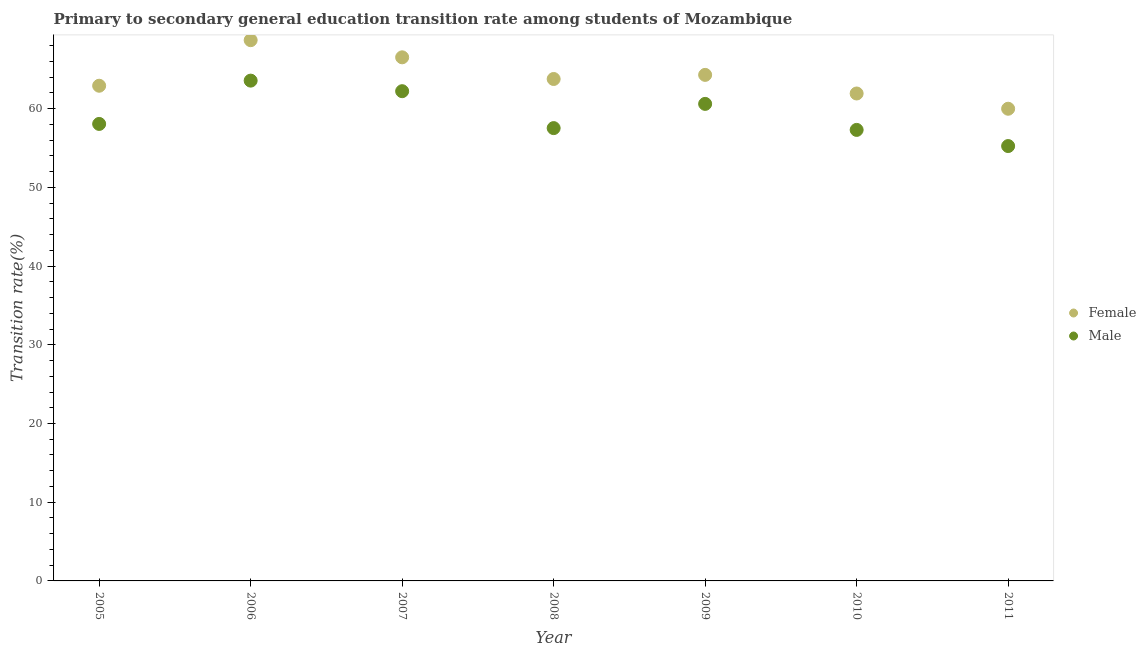Is the number of dotlines equal to the number of legend labels?
Offer a very short reply. Yes. What is the transition rate among female students in 2010?
Your answer should be very brief. 61.92. Across all years, what is the maximum transition rate among female students?
Your response must be concise. 68.7. Across all years, what is the minimum transition rate among male students?
Ensure brevity in your answer.  55.25. What is the total transition rate among female students in the graph?
Your response must be concise. 448.09. What is the difference between the transition rate among male students in 2006 and that in 2010?
Keep it short and to the point. 6.26. What is the difference between the transition rate among male students in 2007 and the transition rate among female students in 2008?
Your response must be concise. -1.55. What is the average transition rate among male students per year?
Ensure brevity in your answer.  59.22. In the year 2008, what is the difference between the transition rate among female students and transition rate among male students?
Give a very brief answer. 6.24. What is the ratio of the transition rate among female students in 2005 to that in 2007?
Make the answer very short. 0.95. Is the transition rate among male students in 2010 less than that in 2011?
Keep it short and to the point. No. What is the difference between the highest and the second highest transition rate among male students?
Ensure brevity in your answer.  1.34. What is the difference between the highest and the lowest transition rate among male students?
Give a very brief answer. 8.31. In how many years, is the transition rate among male students greater than the average transition rate among male students taken over all years?
Make the answer very short. 3. Does the transition rate among female students monotonically increase over the years?
Give a very brief answer. No. Is the transition rate among female students strictly less than the transition rate among male students over the years?
Offer a terse response. No. How many dotlines are there?
Provide a succinct answer. 2. What is the difference between two consecutive major ticks on the Y-axis?
Provide a succinct answer. 10. Where does the legend appear in the graph?
Your response must be concise. Center right. How many legend labels are there?
Make the answer very short. 2. How are the legend labels stacked?
Your response must be concise. Vertical. What is the title of the graph?
Your response must be concise. Primary to secondary general education transition rate among students of Mozambique. Does "DAC donors" appear as one of the legend labels in the graph?
Provide a succinct answer. No. What is the label or title of the X-axis?
Ensure brevity in your answer.  Year. What is the label or title of the Y-axis?
Provide a short and direct response. Transition rate(%). What is the Transition rate(%) in Female in 2005?
Offer a very short reply. 62.91. What is the Transition rate(%) in Male in 2005?
Ensure brevity in your answer.  58.06. What is the Transition rate(%) of Female in 2006?
Offer a very short reply. 68.7. What is the Transition rate(%) of Male in 2006?
Offer a very short reply. 63.56. What is the Transition rate(%) in Female in 2007?
Provide a succinct answer. 66.52. What is the Transition rate(%) of Male in 2007?
Offer a terse response. 62.22. What is the Transition rate(%) of Female in 2008?
Your answer should be very brief. 63.77. What is the Transition rate(%) of Male in 2008?
Offer a very short reply. 57.53. What is the Transition rate(%) in Female in 2009?
Provide a short and direct response. 64.29. What is the Transition rate(%) of Male in 2009?
Provide a short and direct response. 60.6. What is the Transition rate(%) of Female in 2010?
Make the answer very short. 61.92. What is the Transition rate(%) of Male in 2010?
Your answer should be very brief. 57.3. What is the Transition rate(%) in Female in 2011?
Your response must be concise. 59.99. What is the Transition rate(%) of Male in 2011?
Give a very brief answer. 55.25. Across all years, what is the maximum Transition rate(%) of Female?
Give a very brief answer. 68.7. Across all years, what is the maximum Transition rate(%) of Male?
Make the answer very short. 63.56. Across all years, what is the minimum Transition rate(%) in Female?
Your answer should be compact. 59.99. Across all years, what is the minimum Transition rate(%) of Male?
Provide a succinct answer. 55.25. What is the total Transition rate(%) of Female in the graph?
Make the answer very short. 448.09. What is the total Transition rate(%) in Male in the graph?
Provide a succinct answer. 414.51. What is the difference between the Transition rate(%) of Female in 2005 and that in 2006?
Your answer should be compact. -5.79. What is the difference between the Transition rate(%) in Male in 2005 and that in 2006?
Provide a succinct answer. -5.5. What is the difference between the Transition rate(%) in Female in 2005 and that in 2007?
Offer a very short reply. -3.61. What is the difference between the Transition rate(%) in Male in 2005 and that in 2007?
Provide a short and direct response. -4.16. What is the difference between the Transition rate(%) in Female in 2005 and that in 2008?
Give a very brief answer. -0.86. What is the difference between the Transition rate(%) in Male in 2005 and that in 2008?
Ensure brevity in your answer.  0.53. What is the difference between the Transition rate(%) in Female in 2005 and that in 2009?
Your answer should be very brief. -1.38. What is the difference between the Transition rate(%) in Male in 2005 and that in 2009?
Ensure brevity in your answer.  -2.55. What is the difference between the Transition rate(%) in Male in 2005 and that in 2010?
Keep it short and to the point. 0.76. What is the difference between the Transition rate(%) of Female in 2005 and that in 2011?
Offer a terse response. 2.92. What is the difference between the Transition rate(%) of Male in 2005 and that in 2011?
Provide a succinct answer. 2.81. What is the difference between the Transition rate(%) of Female in 2006 and that in 2007?
Provide a short and direct response. 2.18. What is the difference between the Transition rate(%) in Male in 2006 and that in 2007?
Ensure brevity in your answer.  1.34. What is the difference between the Transition rate(%) in Female in 2006 and that in 2008?
Offer a very short reply. 4.93. What is the difference between the Transition rate(%) in Male in 2006 and that in 2008?
Provide a succinct answer. 6.03. What is the difference between the Transition rate(%) in Female in 2006 and that in 2009?
Ensure brevity in your answer.  4.41. What is the difference between the Transition rate(%) of Male in 2006 and that in 2009?
Ensure brevity in your answer.  2.95. What is the difference between the Transition rate(%) of Female in 2006 and that in 2010?
Ensure brevity in your answer.  6.77. What is the difference between the Transition rate(%) in Male in 2006 and that in 2010?
Ensure brevity in your answer.  6.26. What is the difference between the Transition rate(%) of Female in 2006 and that in 2011?
Your response must be concise. 8.71. What is the difference between the Transition rate(%) in Male in 2006 and that in 2011?
Offer a terse response. 8.31. What is the difference between the Transition rate(%) of Female in 2007 and that in 2008?
Provide a short and direct response. 2.75. What is the difference between the Transition rate(%) in Male in 2007 and that in 2008?
Your answer should be compact. 4.69. What is the difference between the Transition rate(%) of Female in 2007 and that in 2009?
Provide a succinct answer. 2.23. What is the difference between the Transition rate(%) in Male in 2007 and that in 2009?
Make the answer very short. 1.61. What is the difference between the Transition rate(%) of Female in 2007 and that in 2010?
Your answer should be very brief. 4.59. What is the difference between the Transition rate(%) in Male in 2007 and that in 2010?
Make the answer very short. 4.92. What is the difference between the Transition rate(%) of Female in 2007 and that in 2011?
Offer a terse response. 6.53. What is the difference between the Transition rate(%) in Male in 2007 and that in 2011?
Provide a succinct answer. 6.97. What is the difference between the Transition rate(%) of Female in 2008 and that in 2009?
Make the answer very short. -0.52. What is the difference between the Transition rate(%) of Male in 2008 and that in 2009?
Provide a succinct answer. -3.08. What is the difference between the Transition rate(%) of Female in 2008 and that in 2010?
Your answer should be compact. 1.84. What is the difference between the Transition rate(%) in Male in 2008 and that in 2010?
Ensure brevity in your answer.  0.23. What is the difference between the Transition rate(%) of Female in 2008 and that in 2011?
Your response must be concise. 3.78. What is the difference between the Transition rate(%) in Male in 2008 and that in 2011?
Offer a very short reply. 2.28. What is the difference between the Transition rate(%) of Female in 2009 and that in 2010?
Ensure brevity in your answer.  2.36. What is the difference between the Transition rate(%) in Male in 2009 and that in 2010?
Your response must be concise. 3.3. What is the difference between the Transition rate(%) in Female in 2009 and that in 2011?
Keep it short and to the point. 4.3. What is the difference between the Transition rate(%) in Male in 2009 and that in 2011?
Offer a terse response. 5.36. What is the difference between the Transition rate(%) in Female in 2010 and that in 2011?
Ensure brevity in your answer.  1.94. What is the difference between the Transition rate(%) in Male in 2010 and that in 2011?
Provide a short and direct response. 2.05. What is the difference between the Transition rate(%) in Female in 2005 and the Transition rate(%) in Male in 2006?
Your answer should be very brief. -0.65. What is the difference between the Transition rate(%) in Female in 2005 and the Transition rate(%) in Male in 2007?
Give a very brief answer. 0.69. What is the difference between the Transition rate(%) in Female in 2005 and the Transition rate(%) in Male in 2008?
Your response must be concise. 5.38. What is the difference between the Transition rate(%) in Female in 2005 and the Transition rate(%) in Male in 2009?
Ensure brevity in your answer.  2.31. What is the difference between the Transition rate(%) of Female in 2005 and the Transition rate(%) of Male in 2010?
Offer a terse response. 5.61. What is the difference between the Transition rate(%) in Female in 2005 and the Transition rate(%) in Male in 2011?
Ensure brevity in your answer.  7.66. What is the difference between the Transition rate(%) of Female in 2006 and the Transition rate(%) of Male in 2007?
Your answer should be compact. 6.48. What is the difference between the Transition rate(%) of Female in 2006 and the Transition rate(%) of Male in 2008?
Keep it short and to the point. 11.17. What is the difference between the Transition rate(%) of Female in 2006 and the Transition rate(%) of Male in 2009?
Offer a very short reply. 8.1. What is the difference between the Transition rate(%) in Female in 2006 and the Transition rate(%) in Male in 2011?
Make the answer very short. 13.45. What is the difference between the Transition rate(%) of Female in 2007 and the Transition rate(%) of Male in 2008?
Provide a succinct answer. 8.99. What is the difference between the Transition rate(%) in Female in 2007 and the Transition rate(%) in Male in 2009?
Provide a succinct answer. 5.92. What is the difference between the Transition rate(%) of Female in 2007 and the Transition rate(%) of Male in 2010?
Make the answer very short. 9.22. What is the difference between the Transition rate(%) in Female in 2007 and the Transition rate(%) in Male in 2011?
Provide a succinct answer. 11.27. What is the difference between the Transition rate(%) in Female in 2008 and the Transition rate(%) in Male in 2009?
Your response must be concise. 3.16. What is the difference between the Transition rate(%) of Female in 2008 and the Transition rate(%) of Male in 2010?
Keep it short and to the point. 6.47. What is the difference between the Transition rate(%) of Female in 2008 and the Transition rate(%) of Male in 2011?
Give a very brief answer. 8.52. What is the difference between the Transition rate(%) of Female in 2009 and the Transition rate(%) of Male in 2010?
Provide a short and direct response. 6.99. What is the difference between the Transition rate(%) in Female in 2009 and the Transition rate(%) in Male in 2011?
Your response must be concise. 9.04. What is the difference between the Transition rate(%) in Female in 2010 and the Transition rate(%) in Male in 2011?
Your answer should be compact. 6.68. What is the average Transition rate(%) of Female per year?
Make the answer very short. 64.01. What is the average Transition rate(%) in Male per year?
Offer a terse response. 59.22. In the year 2005, what is the difference between the Transition rate(%) of Female and Transition rate(%) of Male?
Ensure brevity in your answer.  4.85. In the year 2006, what is the difference between the Transition rate(%) in Female and Transition rate(%) in Male?
Give a very brief answer. 5.14. In the year 2007, what is the difference between the Transition rate(%) in Female and Transition rate(%) in Male?
Keep it short and to the point. 4.3. In the year 2008, what is the difference between the Transition rate(%) of Female and Transition rate(%) of Male?
Give a very brief answer. 6.24. In the year 2009, what is the difference between the Transition rate(%) in Female and Transition rate(%) in Male?
Make the answer very short. 3.69. In the year 2010, what is the difference between the Transition rate(%) in Female and Transition rate(%) in Male?
Your response must be concise. 4.63. In the year 2011, what is the difference between the Transition rate(%) in Female and Transition rate(%) in Male?
Make the answer very short. 4.74. What is the ratio of the Transition rate(%) of Female in 2005 to that in 2006?
Your answer should be very brief. 0.92. What is the ratio of the Transition rate(%) of Male in 2005 to that in 2006?
Provide a succinct answer. 0.91. What is the ratio of the Transition rate(%) in Female in 2005 to that in 2007?
Your response must be concise. 0.95. What is the ratio of the Transition rate(%) of Male in 2005 to that in 2007?
Offer a terse response. 0.93. What is the ratio of the Transition rate(%) of Female in 2005 to that in 2008?
Make the answer very short. 0.99. What is the ratio of the Transition rate(%) in Male in 2005 to that in 2008?
Your response must be concise. 1.01. What is the ratio of the Transition rate(%) of Female in 2005 to that in 2009?
Provide a short and direct response. 0.98. What is the ratio of the Transition rate(%) in Male in 2005 to that in 2009?
Ensure brevity in your answer.  0.96. What is the ratio of the Transition rate(%) of Female in 2005 to that in 2010?
Offer a terse response. 1.02. What is the ratio of the Transition rate(%) of Male in 2005 to that in 2010?
Your response must be concise. 1.01. What is the ratio of the Transition rate(%) of Female in 2005 to that in 2011?
Give a very brief answer. 1.05. What is the ratio of the Transition rate(%) in Male in 2005 to that in 2011?
Your answer should be compact. 1.05. What is the ratio of the Transition rate(%) in Female in 2006 to that in 2007?
Ensure brevity in your answer.  1.03. What is the ratio of the Transition rate(%) in Male in 2006 to that in 2007?
Offer a very short reply. 1.02. What is the ratio of the Transition rate(%) in Female in 2006 to that in 2008?
Keep it short and to the point. 1.08. What is the ratio of the Transition rate(%) in Male in 2006 to that in 2008?
Give a very brief answer. 1.1. What is the ratio of the Transition rate(%) of Female in 2006 to that in 2009?
Make the answer very short. 1.07. What is the ratio of the Transition rate(%) of Male in 2006 to that in 2009?
Make the answer very short. 1.05. What is the ratio of the Transition rate(%) of Female in 2006 to that in 2010?
Offer a very short reply. 1.11. What is the ratio of the Transition rate(%) of Male in 2006 to that in 2010?
Your answer should be very brief. 1.11. What is the ratio of the Transition rate(%) in Female in 2006 to that in 2011?
Offer a very short reply. 1.15. What is the ratio of the Transition rate(%) of Male in 2006 to that in 2011?
Offer a terse response. 1.15. What is the ratio of the Transition rate(%) of Female in 2007 to that in 2008?
Your answer should be compact. 1.04. What is the ratio of the Transition rate(%) of Male in 2007 to that in 2008?
Offer a terse response. 1.08. What is the ratio of the Transition rate(%) of Female in 2007 to that in 2009?
Your response must be concise. 1.03. What is the ratio of the Transition rate(%) of Male in 2007 to that in 2009?
Your answer should be very brief. 1.03. What is the ratio of the Transition rate(%) in Female in 2007 to that in 2010?
Your answer should be compact. 1.07. What is the ratio of the Transition rate(%) of Male in 2007 to that in 2010?
Provide a succinct answer. 1.09. What is the ratio of the Transition rate(%) of Female in 2007 to that in 2011?
Offer a terse response. 1.11. What is the ratio of the Transition rate(%) of Male in 2007 to that in 2011?
Provide a short and direct response. 1.13. What is the ratio of the Transition rate(%) of Female in 2008 to that in 2009?
Give a very brief answer. 0.99. What is the ratio of the Transition rate(%) of Male in 2008 to that in 2009?
Your response must be concise. 0.95. What is the ratio of the Transition rate(%) of Female in 2008 to that in 2010?
Offer a terse response. 1.03. What is the ratio of the Transition rate(%) of Female in 2008 to that in 2011?
Ensure brevity in your answer.  1.06. What is the ratio of the Transition rate(%) of Male in 2008 to that in 2011?
Make the answer very short. 1.04. What is the ratio of the Transition rate(%) of Female in 2009 to that in 2010?
Offer a very short reply. 1.04. What is the ratio of the Transition rate(%) in Male in 2009 to that in 2010?
Ensure brevity in your answer.  1.06. What is the ratio of the Transition rate(%) in Female in 2009 to that in 2011?
Offer a terse response. 1.07. What is the ratio of the Transition rate(%) in Male in 2009 to that in 2011?
Provide a succinct answer. 1.1. What is the ratio of the Transition rate(%) of Female in 2010 to that in 2011?
Ensure brevity in your answer.  1.03. What is the ratio of the Transition rate(%) of Male in 2010 to that in 2011?
Provide a succinct answer. 1.04. What is the difference between the highest and the second highest Transition rate(%) of Female?
Your response must be concise. 2.18. What is the difference between the highest and the second highest Transition rate(%) in Male?
Provide a short and direct response. 1.34. What is the difference between the highest and the lowest Transition rate(%) in Female?
Your answer should be compact. 8.71. What is the difference between the highest and the lowest Transition rate(%) in Male?
Keep it short and to the point. 8.31. 